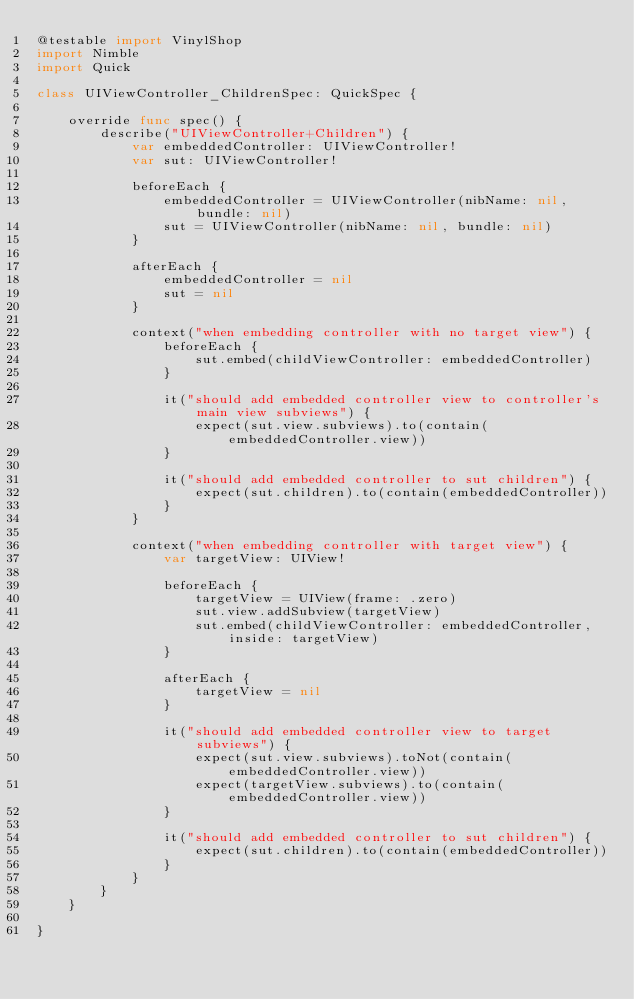Convert code to text. <code><loc_0><loc_0><loc_500><loc_500><_Swift_>@testable import VinylShop
import Nimble
import Quick

class UIViewController_ChildrenSpec: QuickSpec {

    override func spec() {
        describe("UIViewController+Children") {
            var embeddedController: UIViewController!
            var sut: UIViewController!

            beforeEach {
                embeddedController = UIViewController(nibName: nil, bundle: nil)
                sut = UIViewController(nibName: nil, bundle: nil)
            }

            afterEach {
                embeddedController = nil
                sut = nil
            }

            context("when embedding controller with no target view") {
                beforeEach {
                    sut.embed(childViewController: embeddedController)
                }

                it("should add embedded controller view to controller's main view subviews") {
                    expect(sut.view.subviews).to(contain(embeddedController.view))
                }

                it("should add embedded controller to sut children") {
                    expect(sut.children).to(contain(embeddedController))
                }
            }

            context("when embedding controller with target view") {
                var targetView: UIView!

                beforeEach {
                    targetView = UIView(frame: .zero)
                    sut.view.addSubview(targetView)
                    sut.embed(childViewController: embeddedController, inside: targetView)
                }

                afterEach {
                    targetView = nil
                }

                it("should add embedded controller view to target subviews") {
                    expect(sut.view.subviews).toNot(contain(embeddedController.view))
                    expect(targetView.subviews).to(contain(embeddedController.view))
                }

                it("should add embedded controller to sut children") {
                    expect(sut.children).to(contain(embeddedController))
                }
            }
        }
    }

}
</code> 